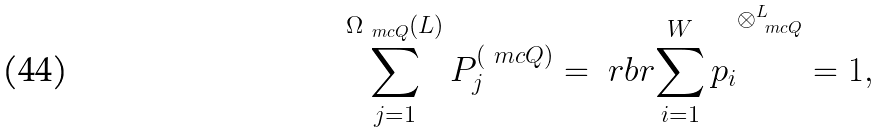Convert formula to latex. <formula><loc_0><loc_0><loc_500><loc_500>\sum _ { j = 1 } ^ { \Omega _ { \ m c { Q } } ( L ) } P _ { j } ^ { ( \ m c { Q } ) } & = \ r b r { \sum _ { i = 1 } ^ { W } p _ { i } } ^ { \otimes _ { \ m c { Q } } ^ { L } } = 1 ,</formula> 